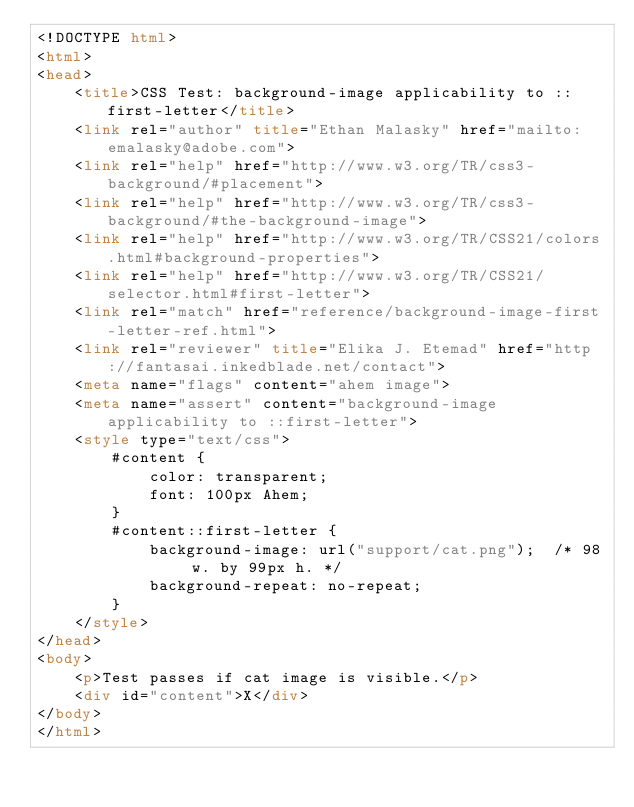<code> <loc_0><loc_0><loc_500><loc_500><_HTML_><!DOCTYPE html>
<html>
<head>
    <title>CSS Test: background-image applicability to ::first-letter</title>
    <link rel="author" title="Ethan Malasky" href="mailto:emalasky@adobe.com">
    <link rel="help" href="http://www.w3.org/TR/css3-background/#placement">
    <link rel="help" href="http://www.w3.org/TR/css3-background/#the-background-image">
    <link rel="help" href="http://www.w3.org/TR/CSS21/colors.html#background-properties">
    <link rel="help" href="http://www.w3.org/TR/CSS21/selector.html#first-letter">
    <link rel="match" href="reference/background-image-first-letter-ref.html">
    <link rel="reviewer" title="Elika J. Etemad" href="http://fantasai.inkedblade.net/contact">
    <meta name="flags" content="ahem image">
    <meta name="assert" content="background-image applicability to ::first-letter">
    <style type="text/css">
        #content {
            color: transparent;
            font: 100px Ahem;
        }
        #content::first-letter {
            background-image: url("support/cat.png");  /* 98 w. by 99px h. */
            background-repeat: no-repeat;
        }
    </style>
</head>
<body>
    <p>Test passes if cat image is visible.</p>
    <div id="content">X</div>
</body>
</html>
</code> 